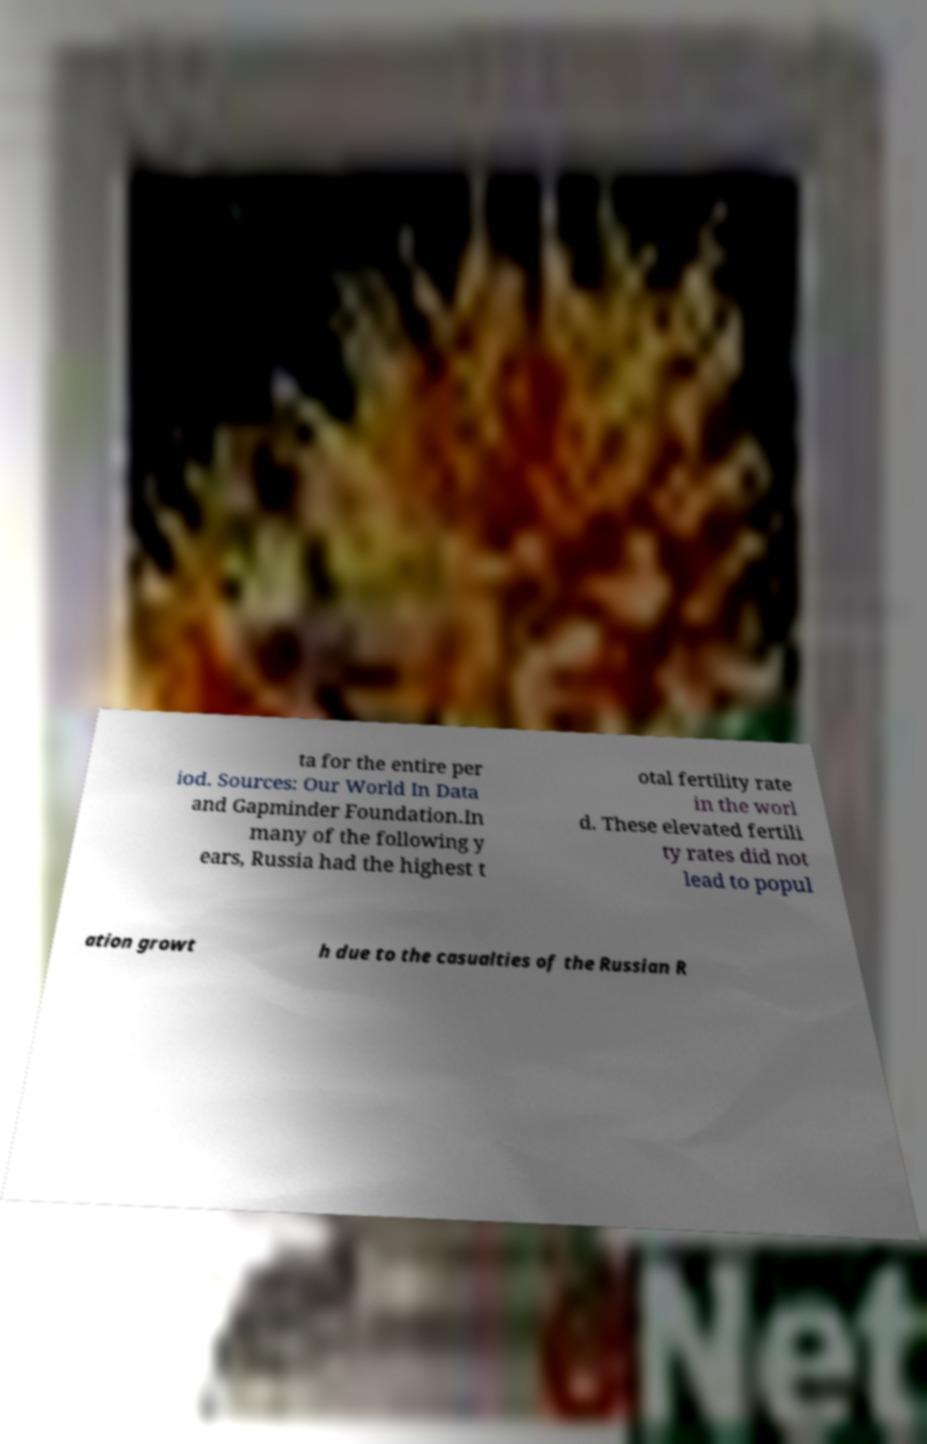What messages or text are displayed in this image? I need them in a readable, typed format. ta for the entire per iod. Sources: Our World In Data and Gapminder Foundation.In many of the following y ears, Russia had the highest t otal fertility rate in the worl d. These elevated fertili ty rates did not lead to popul ation growt h due to the casualties of the Russian R 